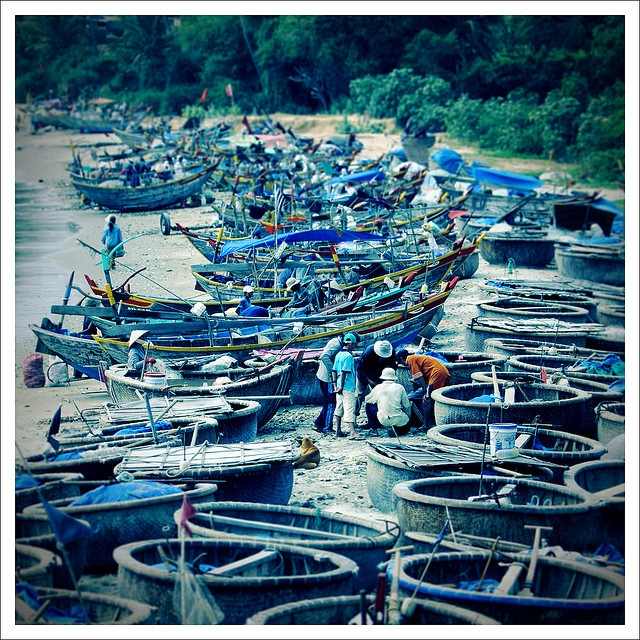Describe the objects in this image and their specific colors. I can see boat in black, navy, white, and blue tones, boat in black, navy, teal, and darkgray tones, boat in black, lightgray, navy, and teal tones, boat in black, navy, teal, and blue tones, and boat in black, navy, white, and teal tones in this image. 